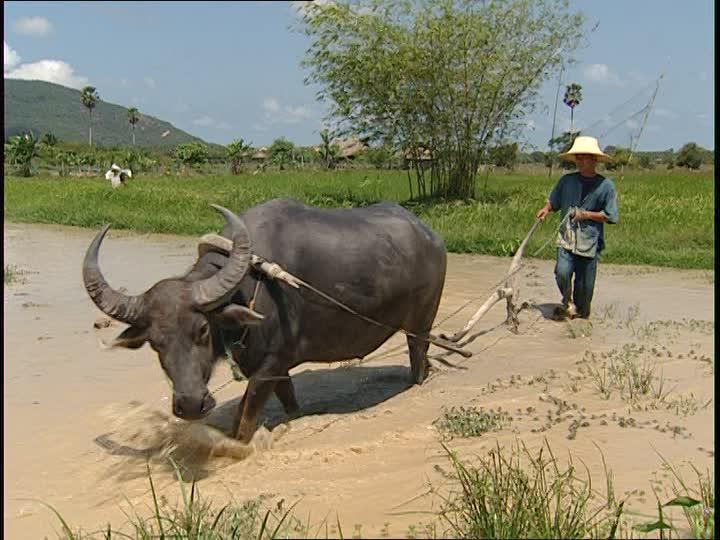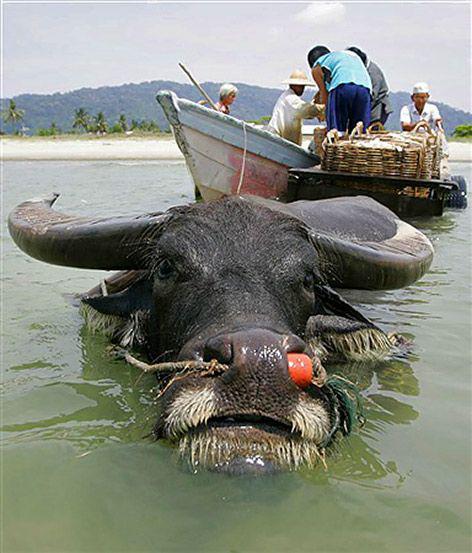The first image is the image on the left, the second image is the image on the right. For the images displayed, is the sentence "At least one water buffalo is standing in water." factually correct? Answer yes or no. Yes. The first image is the image on the left, the second image is the image on the right. For the images displayed, is the sentence "Right image shows one ox with a rope looped through its nose, walking in water." factually correct? Answer yes or no. Yes. 